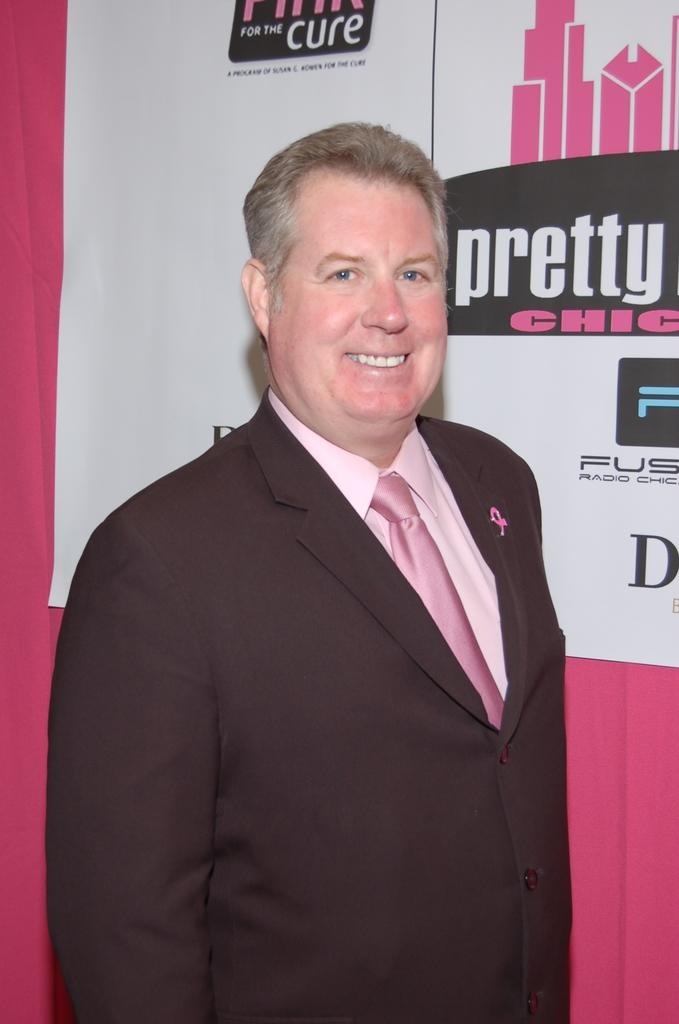<image>
Create a compact narrative representing the image presented. a man that is next to a pretty sign 